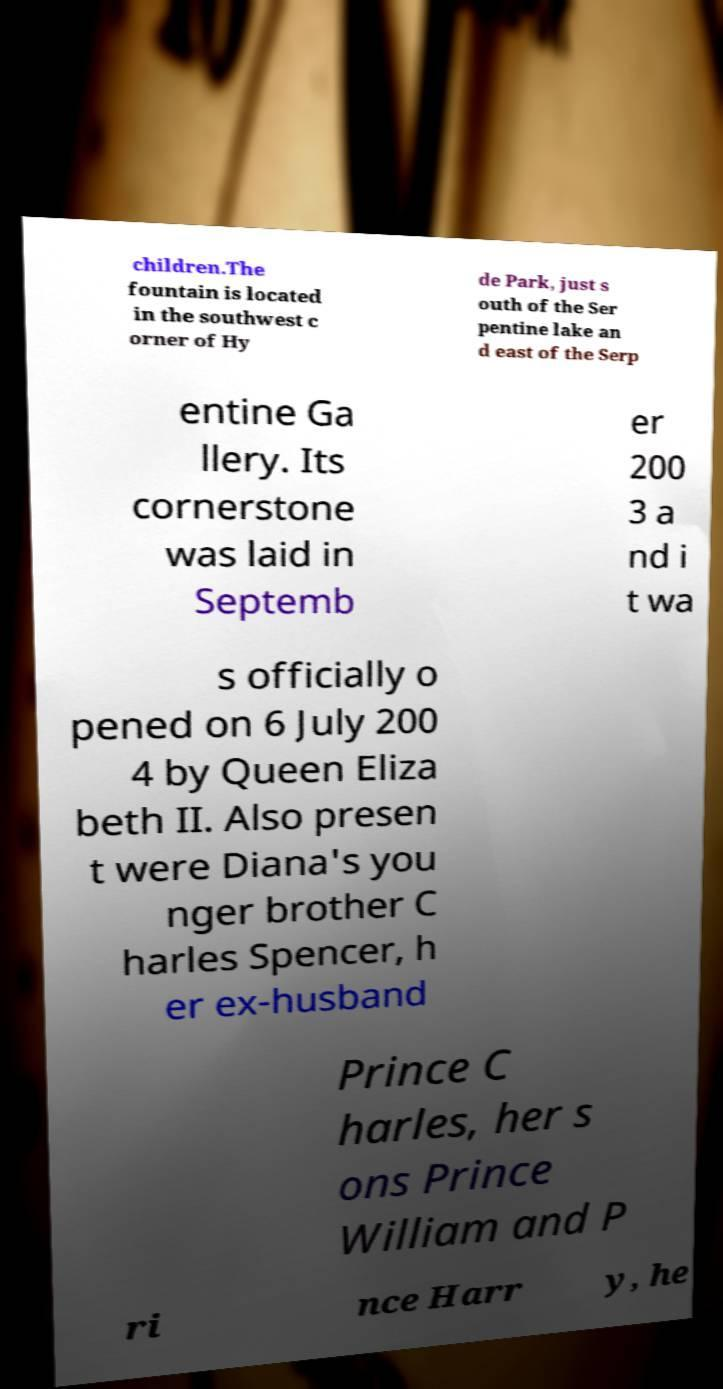Can you read and provide the text displayed in the image?This photo seems to have some interesting text. Can you extract and type it out for me? children.The fountain is located in the southwest c orner of Hy de Park, just s outh of the Ser pentine lake an d east of the Serp entine Ga llery. Its cornerstone was laid in Septemb er 200 3 a nd i t wa s officially o pened on 6 July 200 4 by Queen Eliza beth II. Also presen t were Diana's you nger brother C harles Spencer, h er ex-husband Prince C harles, her s ons Prince William and P ri nce Harr y, he 